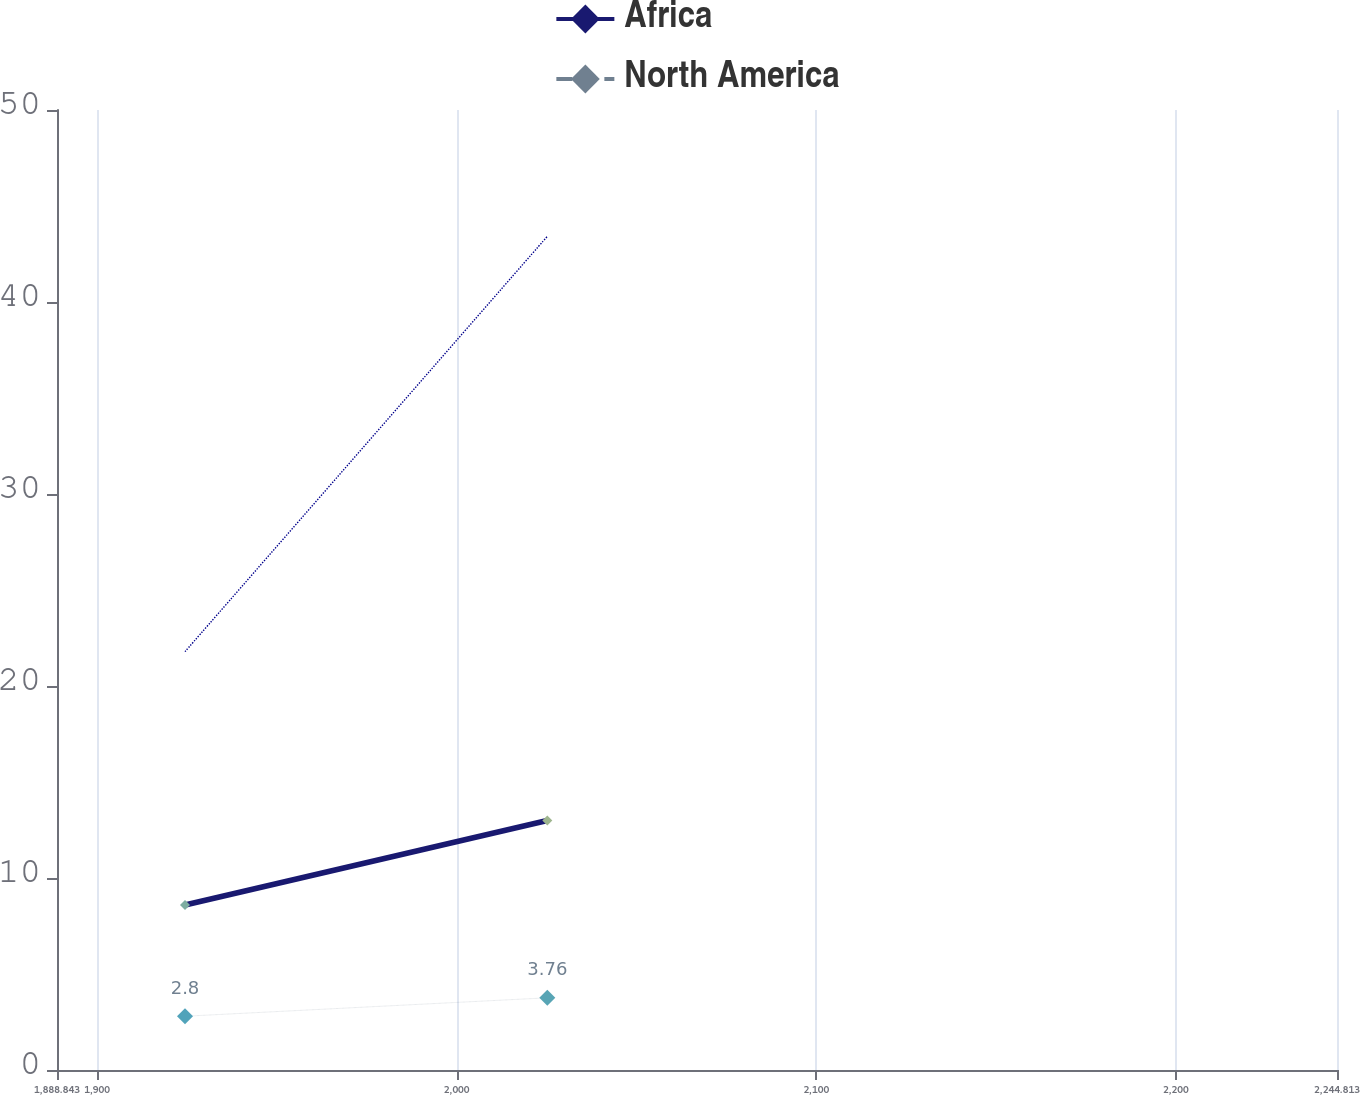Convert chart to OTSL. <chart><loc_0><loc_0><loc_500><loc_500><line_chart><ecel><fcel>Africa<fcel>North America<fcel>Unnamed: 3<nl><fcel>1924.44<fcel>8.59<fcel>2.8<fcel>21.79<nl><fcel>2025.2<fcel>12.99<fcel>3.76<fcel>43.42<nl><fcel>2280.41<fcel>16.19<fcel>2.69<fcel>36.18<nl></chart> 